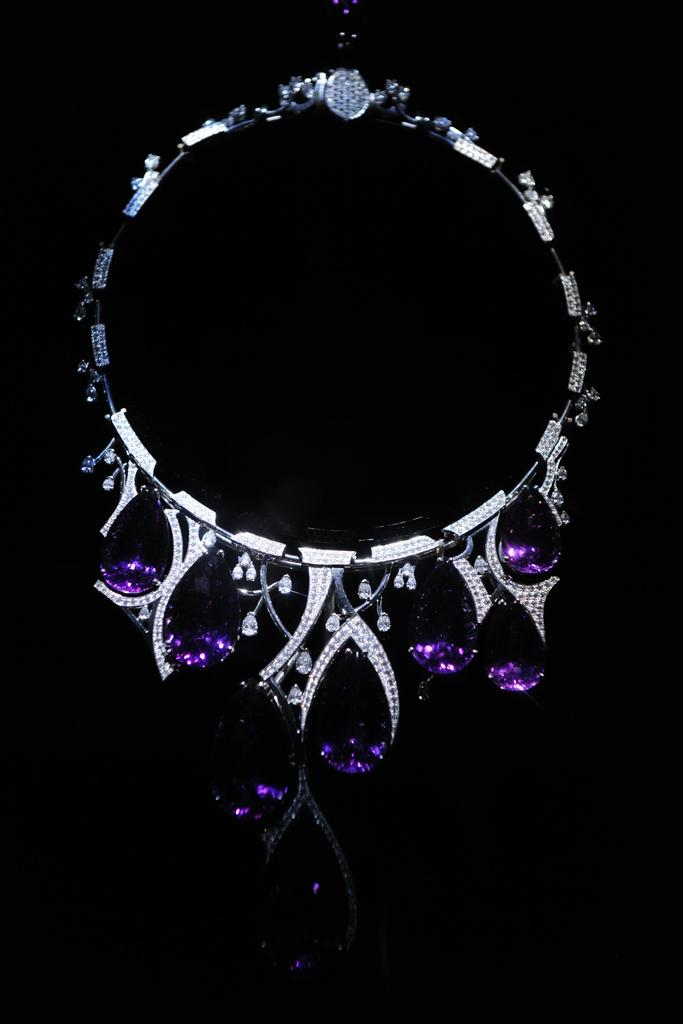What is the overall tone or appearance of the image? The picture is dark. What type of objects can be seen in the image? There is jewelry visible in the image. What type of vessel is being used to create friction in the image? There is no vessel or friction present in the image; it only features jewelry in a dark setting. 